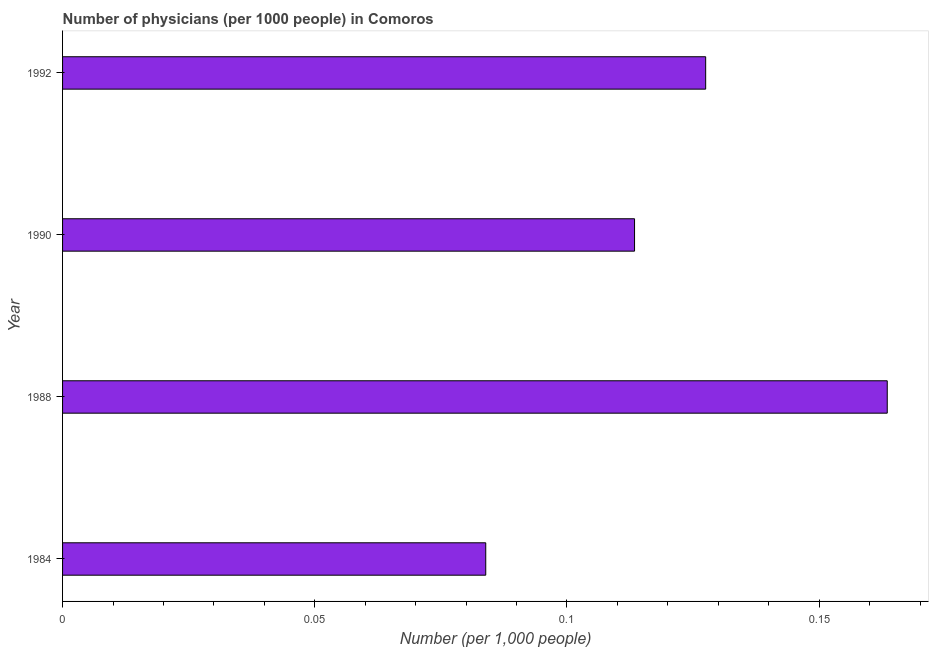Does the graph contain any zero values?
Offer a terse response. No. Does the graph contain grids?
Offer a very short reply. No. What is the title of the graph?
Offer a terse response. Number of physicians (per 1000 people) in Comoros. What is the label or title of the X-axis?
Your response must be concise. Number (per 1,0 people). What is the number of physicians in 1990?
Keep it short and to the point. 0.11. Across all years, what is the maximum number of physicians?
Make the answer very short. 0.16. Across all years, what is the minimum number of physicians?
Keep it short and to the point. 0.08. In which year was the number of physicians maximum?
Make the answer very short. 1988. What is the sum of the number of physicians?
Provide a short and direct response. 0.49. What is the difference between the number of physicians in 1984 and 1990?
Your answer should be compact. -0.03. What is the average number of physicians per year?
Your answer should be very brief. 0.12. What is the median number of physicians?
Your answer should be compact. 0.12. What is the ratio of the number of physicians in 1984 to that in 1988?
Keep it short and to the point. 0.51. Is the number of physicians in 1984 less than that in 1990?
Provide a short and direct response. Yes. What is the difference between the highest and the second highest number of physicians?
Your answer should be very brief. 0.04. Is the sum of the number of physicians in 1988 and 1990 greater than the maximum number of physicians across all years?
Provide a succinct answer. Yes. In how many years, is the number of physicians greater than the average number of physicians taken over all years?
Give a very brief answer. 2. Are all the bars in the graph horizontal?
Provide a succinct answer. Yes. How many years are there in the graph?
Your response must be concise. 4. Are the values on the major ticks of X-axis written in scientific E-notation?
Offer a terse response. No. What is the Number (per 1,000 people) of 1984?
Provide a succinct answer. 0.08. What is the Number (per 1,000 people) in 1988?
Your response must be concise. 0.16. What is the Number (per 1,000 people) in 1990?
Provide a short and direct response. 0.11. What is the Number (per 1,000 people) of 1992?
Your answer should be very brief. 0.13. What is the difference between the Number (per 1,000 people) in 1984 and 1988?
Provide a succinct answer. -0.08. What is the difference between the Number (per 1,000 people) in 1984 and 1990?
Make the answer very short. -0.03. What is the difference between the Number (per 1,000 people) in 1984 and 1992?
Make the answer very short. -0.04. What is the difference between the Number (per 1,000 people) in 1988 and 1990?
Keep it short and to the point. 0.05. What is the difference between the Number (per 1,000 people) in 1988 and 1992?
Provide a succinct answer. 0.04. What is the difference between the Number (per 1,000 people) in 1990 and 1992?
Offer a very short reply. -0.01. What is the ratio of the Number (per 1,000 people) in 1984 to that in 1988?
Ensure brevity in your answer.  0.51. What is the ratio of the Number (per 1,000 people) in 1984 to that in 1990?
Provide a short and direct response. 0.74. What is the ratio of the Number (per 1,000 people) in 1984 to that in 1992?
Provide a short and direct response. 0.66. What is the ratio of the Number (per 1,000 people) in 1988 to that in 1990?
Provide a short and direct response. 1.44. What is the ratio of the Number (per 1,000 people) in 1988 to that in 1992?
Your answer should be very brief. 1.28. What is the ratio of the Number (per 1,000 people) in 1990 to that in 1992?
Make the answer very short. 0.89. 